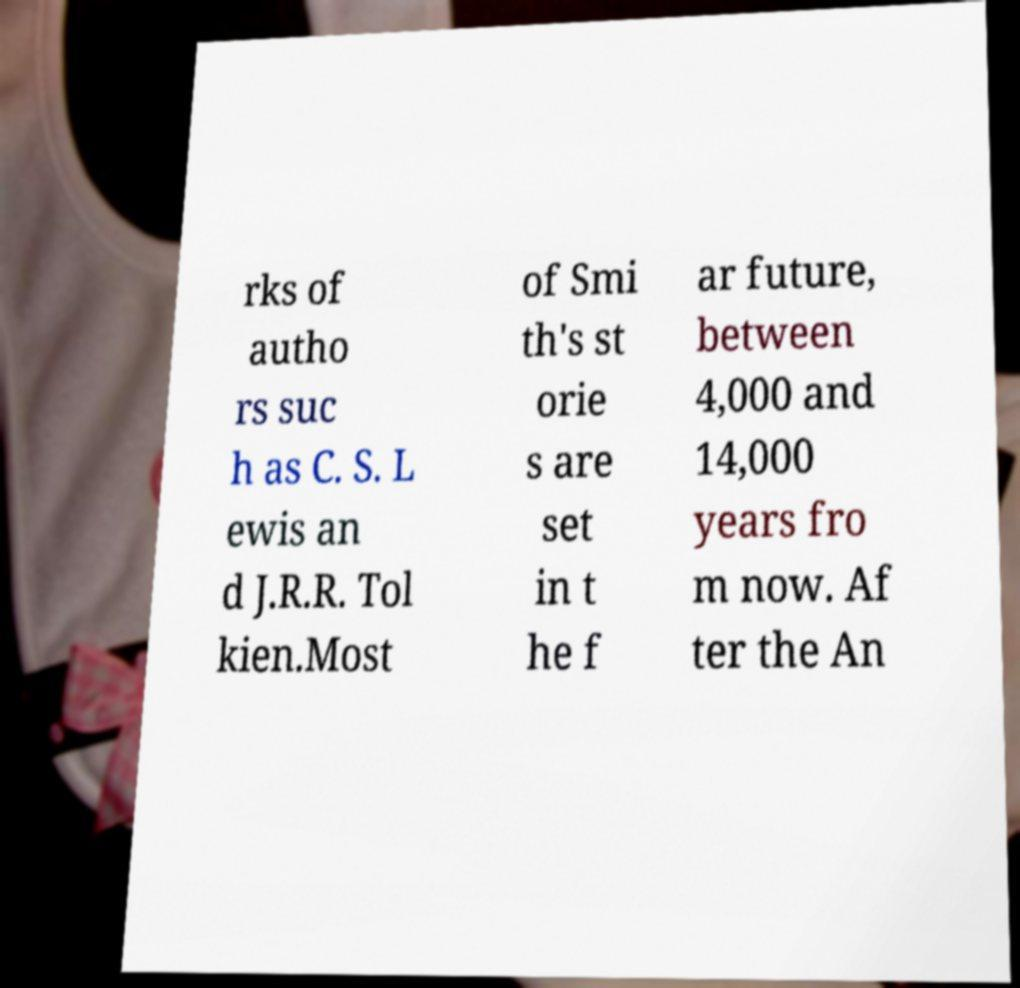I need the written content from this picture converted into text. Can you do that? rks of autho rs suc h as C. S. L ewis an d J.R.R. Tol kien.Most of Smi th's st orie s are set in t he f ar future, between 4,000 and 14,000 years fro m now. Af ter the An 